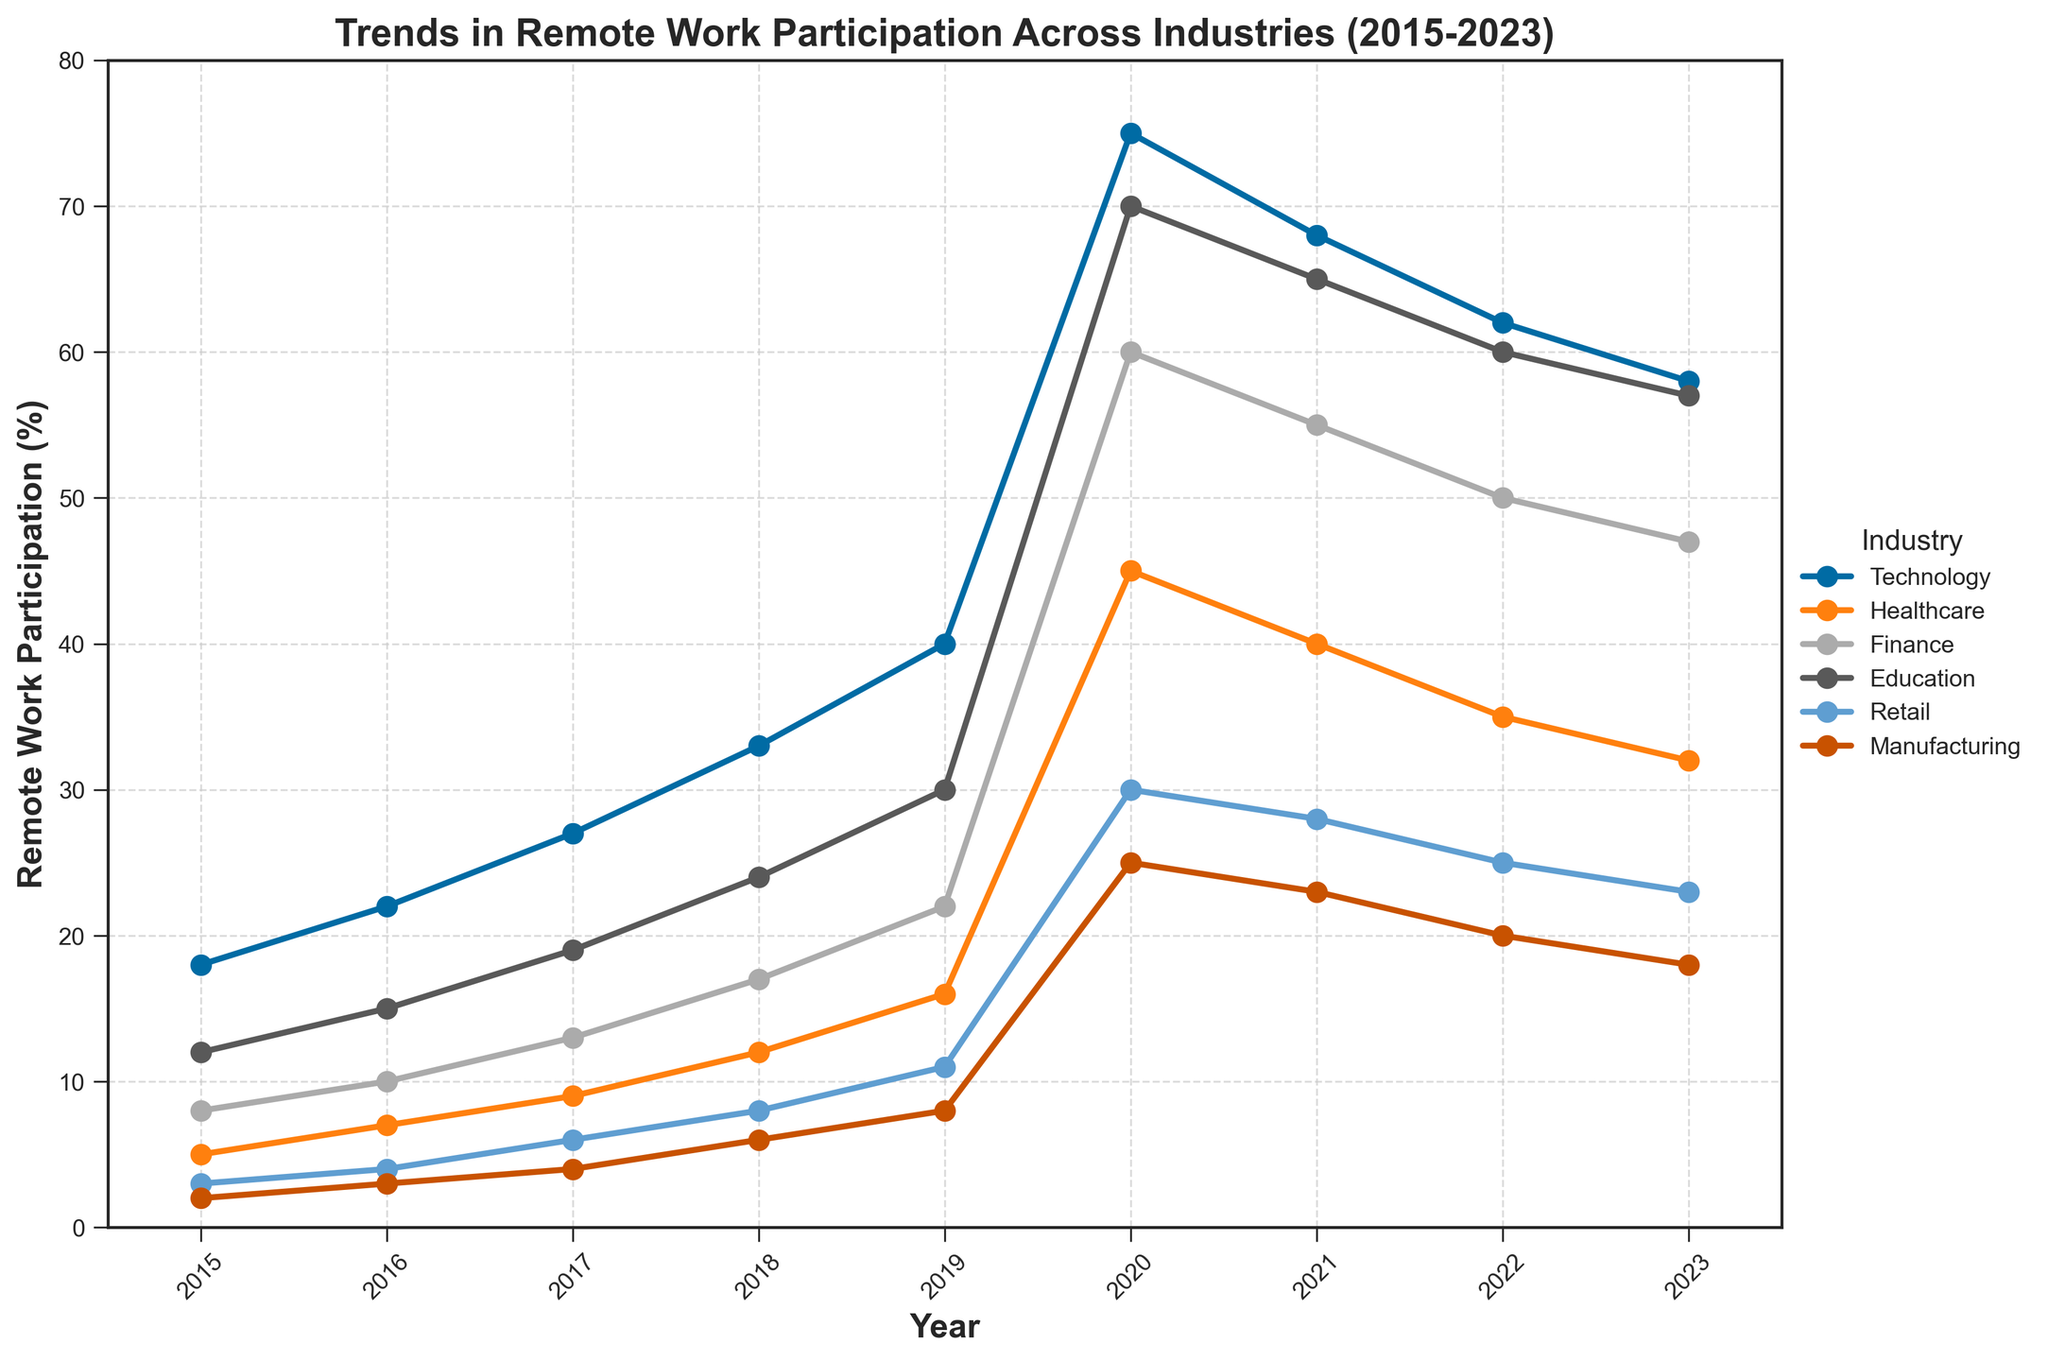Which industry had the highest remote work participation in 2023? By observing the height of the lines on the plot and reading the labels, we see that the Technology industry had the highest remote work participation rate in 2023.
Answer: Technology In which year did the Healthcare industry see the most significant increase in remote work participation? By comparing the slopes between consecutive years for the Healthcare industry (orange line), the year with the steepest slope is between 2019 and 2020, indicating the most significant increase.
Answer: 2020 What is the average remote work participation rate in the Education industry from 2015 to 2023? To find the average, sum the remote work participation percentages for the Education industry over all years (12 + 15 + 19 + 24 + 30 + 70 + 65 + 60 + 57 = 352) and divide by the number of years (9). So, the average is 352 / 9.
Answer: 39.11 Between the Finance and Retail industries, which had greater remote work participation in 2020? By comparing the heights of the corresponding lines for 2020 on the plot, Finance had a participation rate of 60%, while Retail had 30%. Thus, Finance had greater remote work participation in 2020.
Answer: Finance How many times did the Manufacturing industry's remote work participation rate decrease from one year to the next between 2016 and 2023? By observing the Manufacturing line (red) on the plot and noting downward trends between consecutive years, we see decreases from 2020 to 2021, 2021 to 2022, and 2022 to 2023. This happened 3 times.
Answer: 3 Which year saw the highest remote work participation rate overall across all industries? By scanning the highest points of each line on the plot, we find that 2020 had the highest individual peak (Technology at 75%).
Answer: 2020 From 2019 to 2023, which industry's remote work participation declined the most? By comparing the decline in remote work participation rates from 2019 to 2023 across all industry lines on the plot: Technology (75% to 58% => 17%), Healthcare (45% to 32% => 13%), Finance (60% to 47% => 13%), Education (70% to 57% => 13%), Retail (30% to 23% => 7%), and Manufacturing (25% to 18% => 7%), Technology experienced the most significant drop (17%).
Answer: Technology What was the total remote work participation rate for Technology and Education combined in 2018? By observing the plot, the Technology rate was 33%, and the Education rate was 24%. Summing them gives 33 + 24 = 57%.
Answer: 57% Did any industry have a constant rate of remote work participation between any consecutive years? By observing the graph, there is no industry with a perfectly horizontal line between any consecutive years from 2015 to 2023, indicating no constant remote work participation rates in the given years.
Answer: No Compare the remote work participation rates of Technology and Healthcare industries in 2017. Which was higher and by how much? In 2017, Technology had a participation rate of 27%, and Healthcare had 9%. The difference is 27 - 9 = 18%.
Answer: Technology, by 18% 